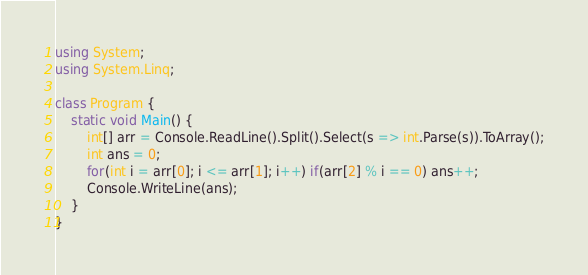<code> <loc_0><loc_0><loc_500><loc_500><_C#_>using System;
using System.Linq;

class Program {
    static void Main() {
        int[] arr = Console.ReadLine().Split().Select(s => int.Parse(s)).ToArray();
        int ans = 0;
        for(int i = arr[0]; i <= arr[1]; i++) if(arr[2] % i == 0) ans++;
        Console.WriteLine(ans);
    }
}
</code> 